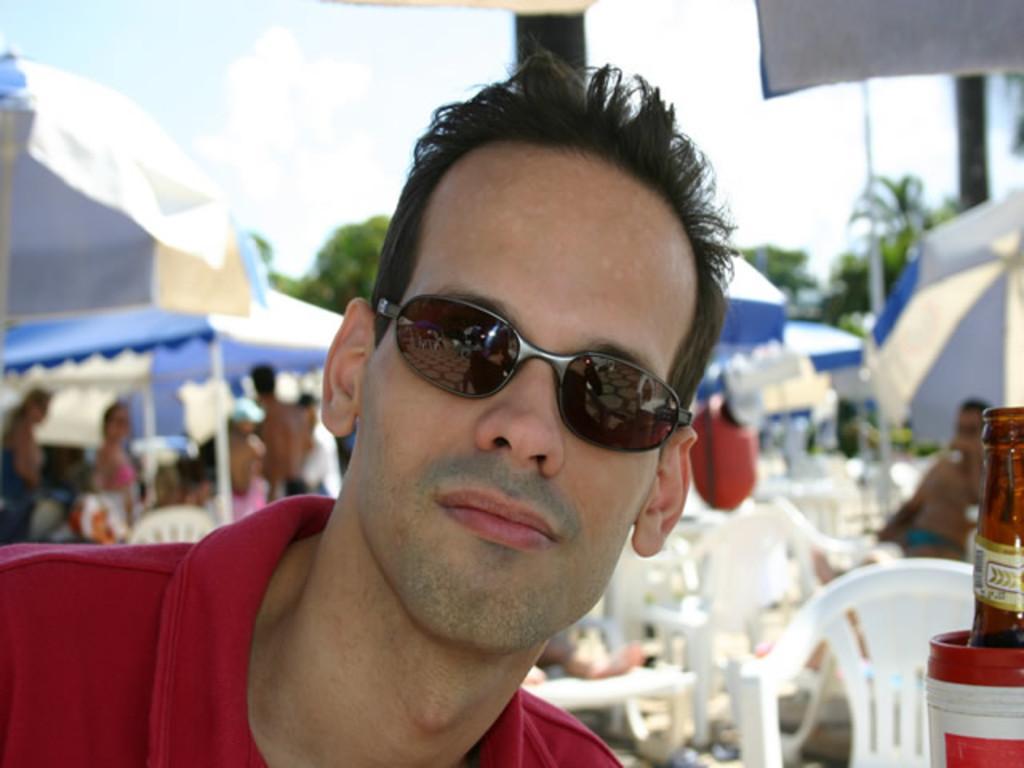How would you summarize this image in a sentence or two? At the top we can see sky with clouds. These are trees. Here we can see few tents and under this tent there are few persons sitting and standing on the chairs. Here in front of the picture we can see one man, wearing goggles. At the right side of the picture we can see a bottle. 